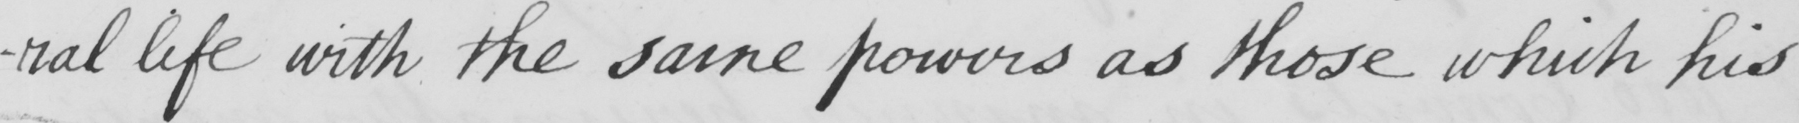What does this handwritten line say? -ral life with the same powers as those which his 